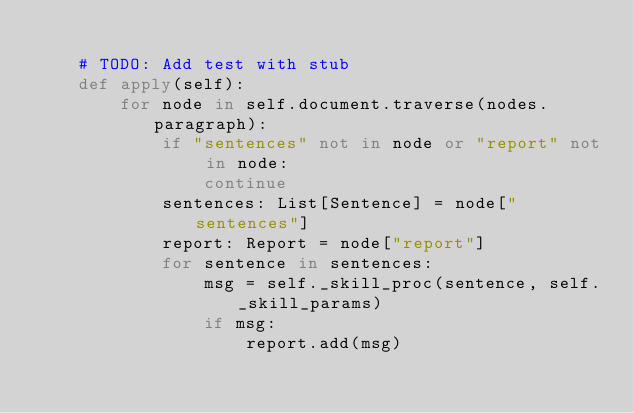<code> <loc_0><loc_0><loc_500><loc_500><_Python_>
    # TODO: Add test with stub
    def apply(self):
        for node in self.document.traverse(nodes.paragraph):
            if "sentences" not in node or "report" not in node:
                continue
            sentences: List[Sentence] = node["sentences"]
            report: Report = node["report"]
            for sentence in sentences:
                msg = self._skill_proc(sentence, self._skill_params)
                if msg:
                    report.add(msg)
</code> 